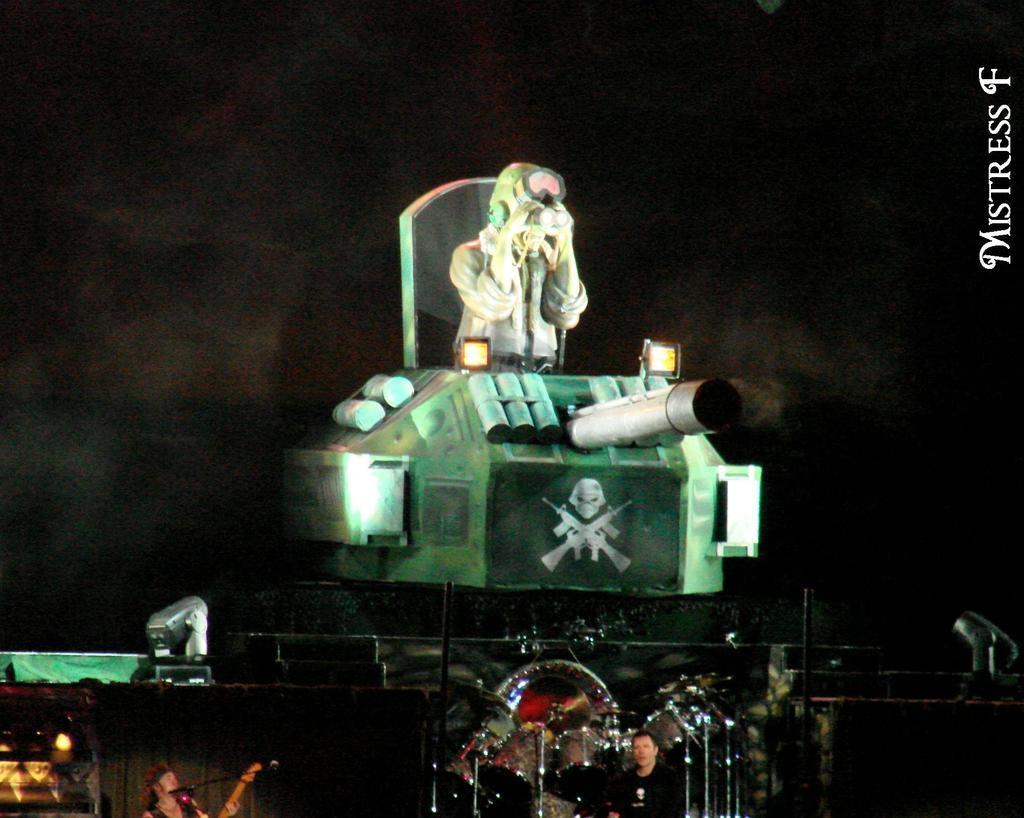Please provide a concise description of this image. In this picture we can see three people, drums, poles, lights, mic, danger sign and some objects and a man holding a guitar and in the background it is dark. 